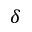<formula> <loc_0><loc_0><loc_500><loc_500>\delta</formula> 